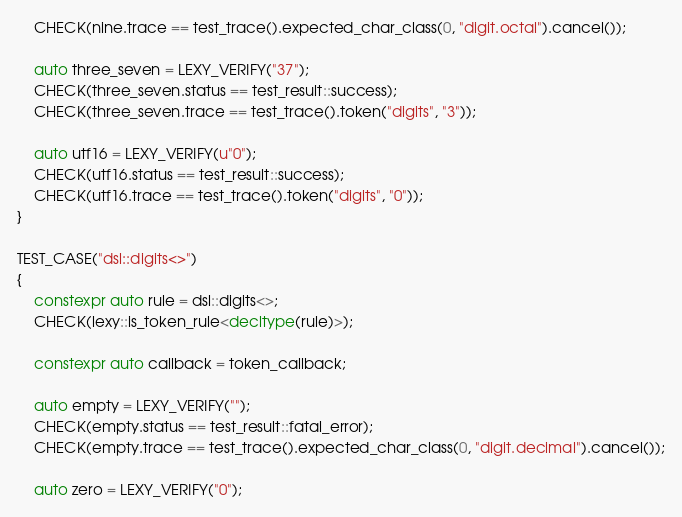Convert code to text. <code><loc_0><loc_0><loc_500><loc_500><_C++_>    CHECK(nine.trace == test_trace().expected_char_class(0, "digit.octal").cancel());

    auto three_seven = LEXY_VERIFY("37");
    CHECK(three_seven.status == test_result::success);
    CHECK(three_seven.trace == test_trace().token("digits", "3"));

    auto utf16 = LEXY_VERIFY(u"0");
    CHECK(utf16.status == test_result::success);
    CHECK(utf16.trace == test_trace().token("digits", "0"));
}

TEST_CASE("dsl::digits<>")
{
    constexpr auto rule = dsl::digits<>;
    CHECK(lexy::is_token_rule<decltype(rule)>);

    constexpr auto callback = token_callback;

    auto empty = LEXY_VERIFY("");
    CHECK(empty.status == test_result::fatal_error);
    CHECK(empty.trace == test_trace().expected_char_class(0, "digit.decimal").cancel());

    auto zero = LEXY_VERIFY("0");</code> 